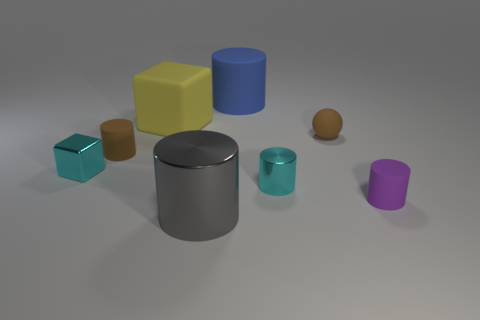There is a small cyan thing that is the same shape as the blue rubber object; what is it made of?
Ensure brevity in your answer.  Metal. There is a large rubber block; how many big gray shiny things are in front of it?
Give a very brief answer. 1. There is a brown object on the left side of the big yellow object; is its shape the same as the gray thing that is in front of the blue rubber thing?
Make the answer very short. Yes. What is the shape of the metal object that is on the right side of the brown cylinder and behind the tiny purple rubber object?
Your response must be concise. Cylinder. There is a blue cylinder that is the same material as the purple cylinder; what size is it?
Your response must be concise. Large. Is the number of yellow things less than the number of blue cubes?
Offer a very short reply. No. What material is the big cylinder in front of the tiny brown matte ball to the right of the small cyan thing right of the big metallic cylinder?
Your response must be concise. Metal. Are the cyan thing right of the large blue object and the small cylinder behind the small cyan block made of the same material?
Your answer should be compact. No. There is a rubber object that is behind the small brown rubber cylinder and left of the gray thing; how big is it?
Offer a very short reply. Large. What material is the cyan block that is the same size as the brown matte cylinder?
Offer a very short reply. Metal. 